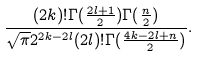Convert formula to latex. <formula><loc_0><loc_0><loc_500><loc_500>\frac { ( 2 k ) ! \Gamma ( \frac { 2 l + 1 } { 2 } ) \Gamma ( \frac { n } { 2 } ) } { \sqrt { \pi } 2 ^ { 2 k - 2 l } ( 2 l ) ! \Gamma ( \frac { 4 k - 2 l + n } { 2 } ) } .</formula> 